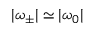Convert formula to latex. <formula><loc_0><loc_0><loc_500><loc_500>| \omega _ { \pm } | \simeq | \omega _ { 0 } |</formula> 